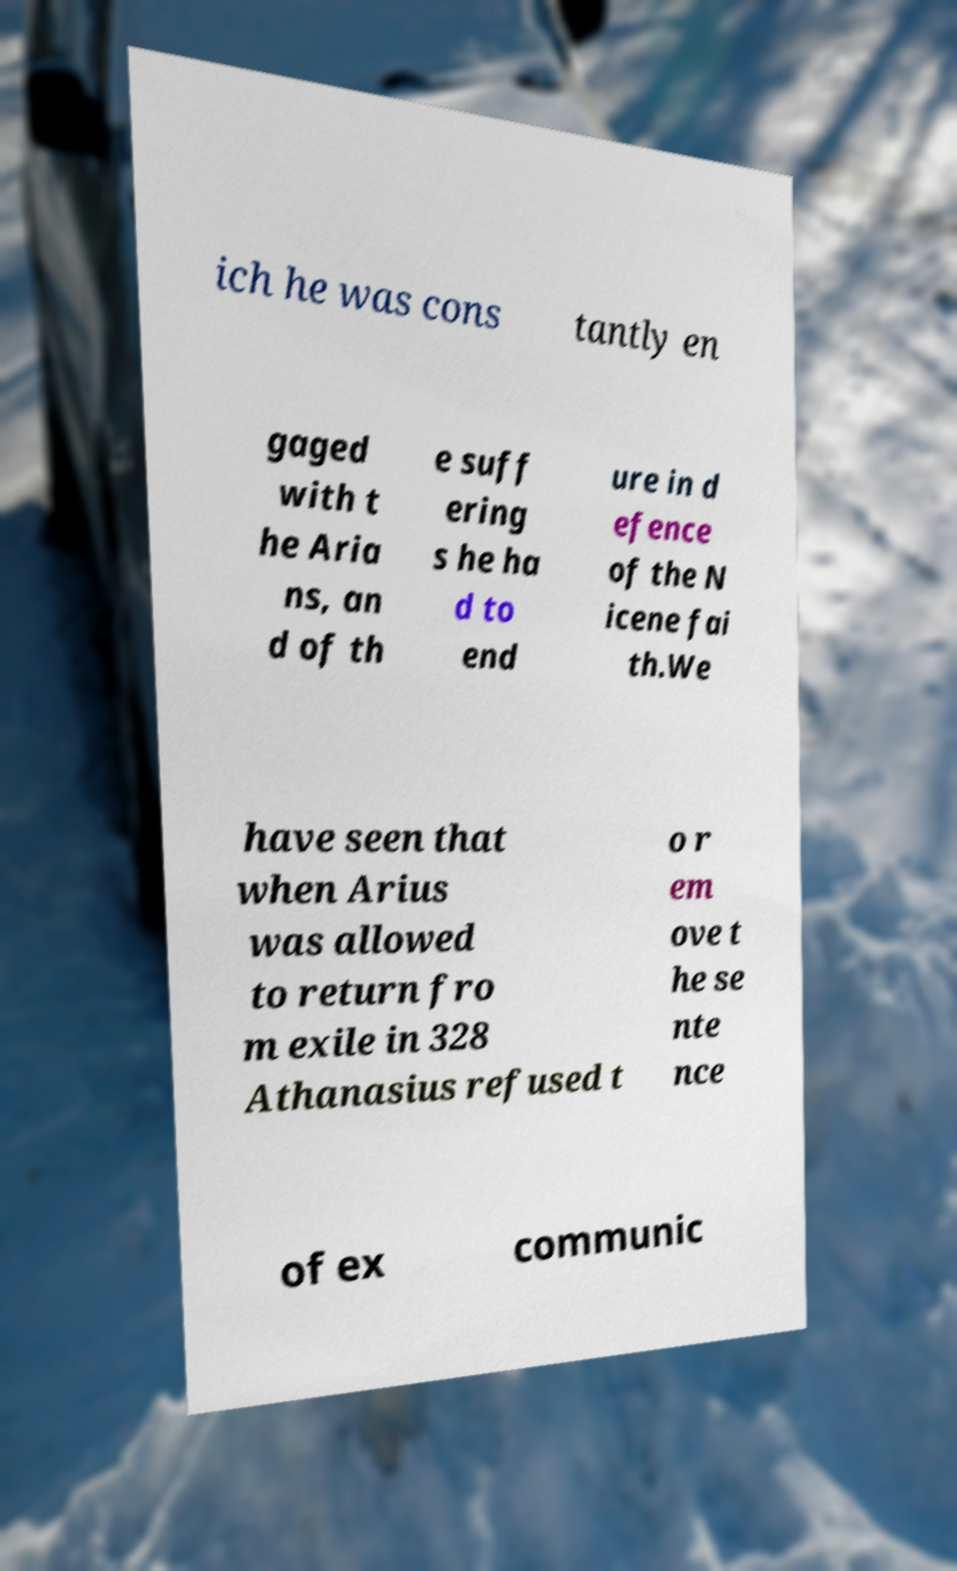There's text embedded in this image that I need extracted. Can you transcribe it verbatim? ich he was cons tantly en gaged with t he Aria ns, an d of th e suff ering s he ha d to end ure in d efence of the N icene fai th.We have seen that when Arius was allowed to return fro m exile in 328 Athanasius refused t o r em ove t he se nte nce of ex communic 